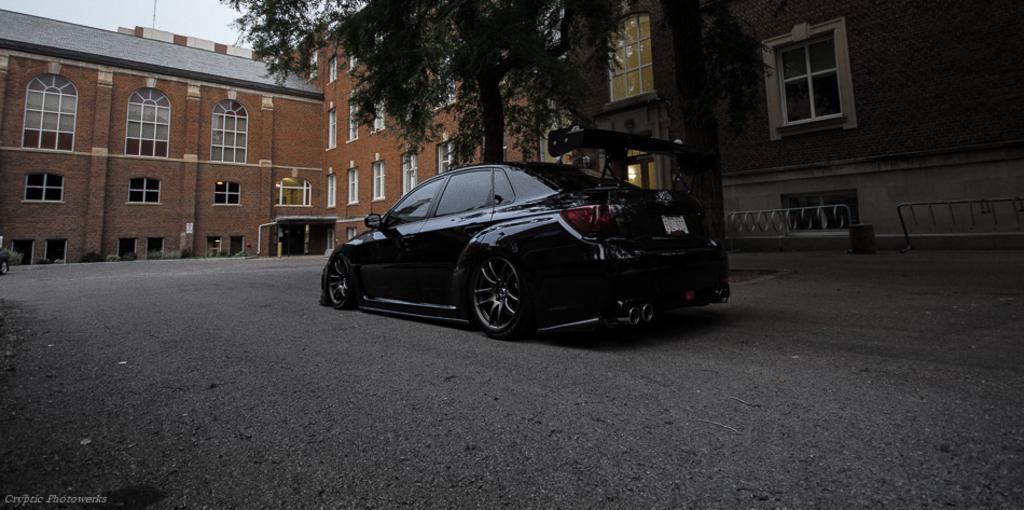In one or two sentences, can you explain what this image depicts? In this image we can see motor vehicle on the road, buildings, iron grills, bins, electric lights, windows, trees and sky. 